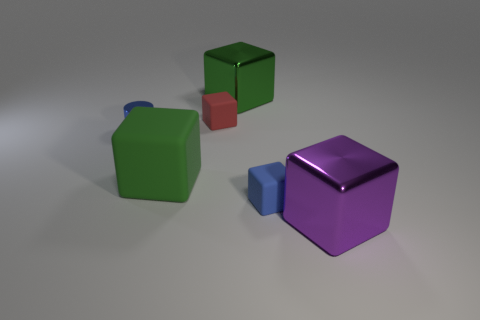Subtract all tiny red rubber blocks. How many blocks are left? 4 Subtract 2 blocks. How many blocks are left? 3 Subtract all red blocks. How many blocks are left? 4 Subtract all yellow cubes. Subtract all brown cylinders. How many cubes are left? 5 Add 3 tiny matte cubes. How many objects exist? 9 Subtract all cylinders. How many objects are left? 5 Subtract all purple metallic blocks. Subtract all large green blocks. How many objects are left? 3 Add 2 large purple cubes. How many large purple cubes are left? 3 Add 4 tiny purple cubes. How many tiny purple cubes exist? 4 Subtract 0 gray cylinders. How many objects are left? 6 